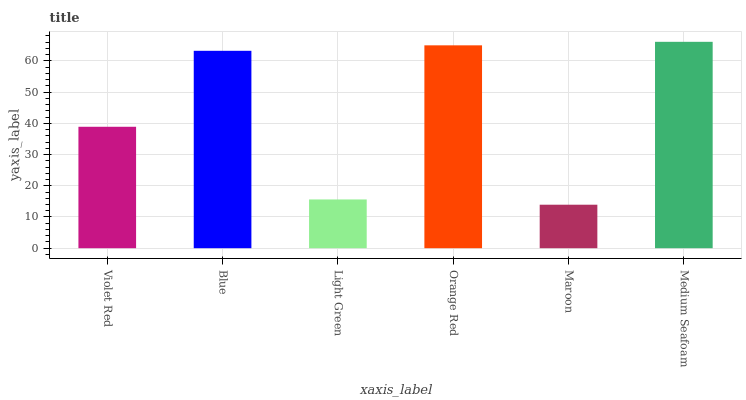Is Maroon the minimum?
Answer yes or no. Yes. Is Medium Seafoam the maximum?
Answer yes or no. Yes. Is Blue the minimum?
Answer yes or no. No. Is Blue the maximum?
Answer yes or no. No. Is Blue greater than Violet Red?
Answer yes or no. Yes. Is Violet Red less than Blue?
Answer yes or no. Yes. Is Violet Red greater than Blue?
Answer yes or no. No. Is Blue less than Violet Red?
Answer yes or no. No. Is Blue the high median?
Answer yes or no. Yes. Is Violet Red the low median?
Answer yes or no. Yes. Is Maroon the high median?
Answer yes or no. No. Is Maroon the low median?
Answer yes or no. No. 